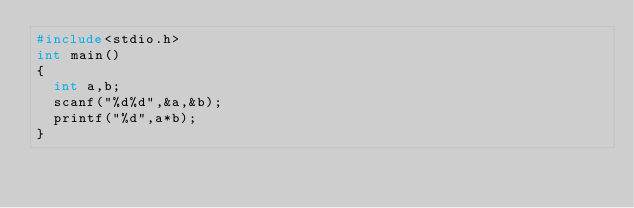Convert code to text. <code><loc_0><loc_0><loc_500><loc_500><_C_>#include<stdio.h>
int main()
{
  int a,b;
  scanf("%d%d",&a,&b);
  printf("%d",a*b);
}</code> 